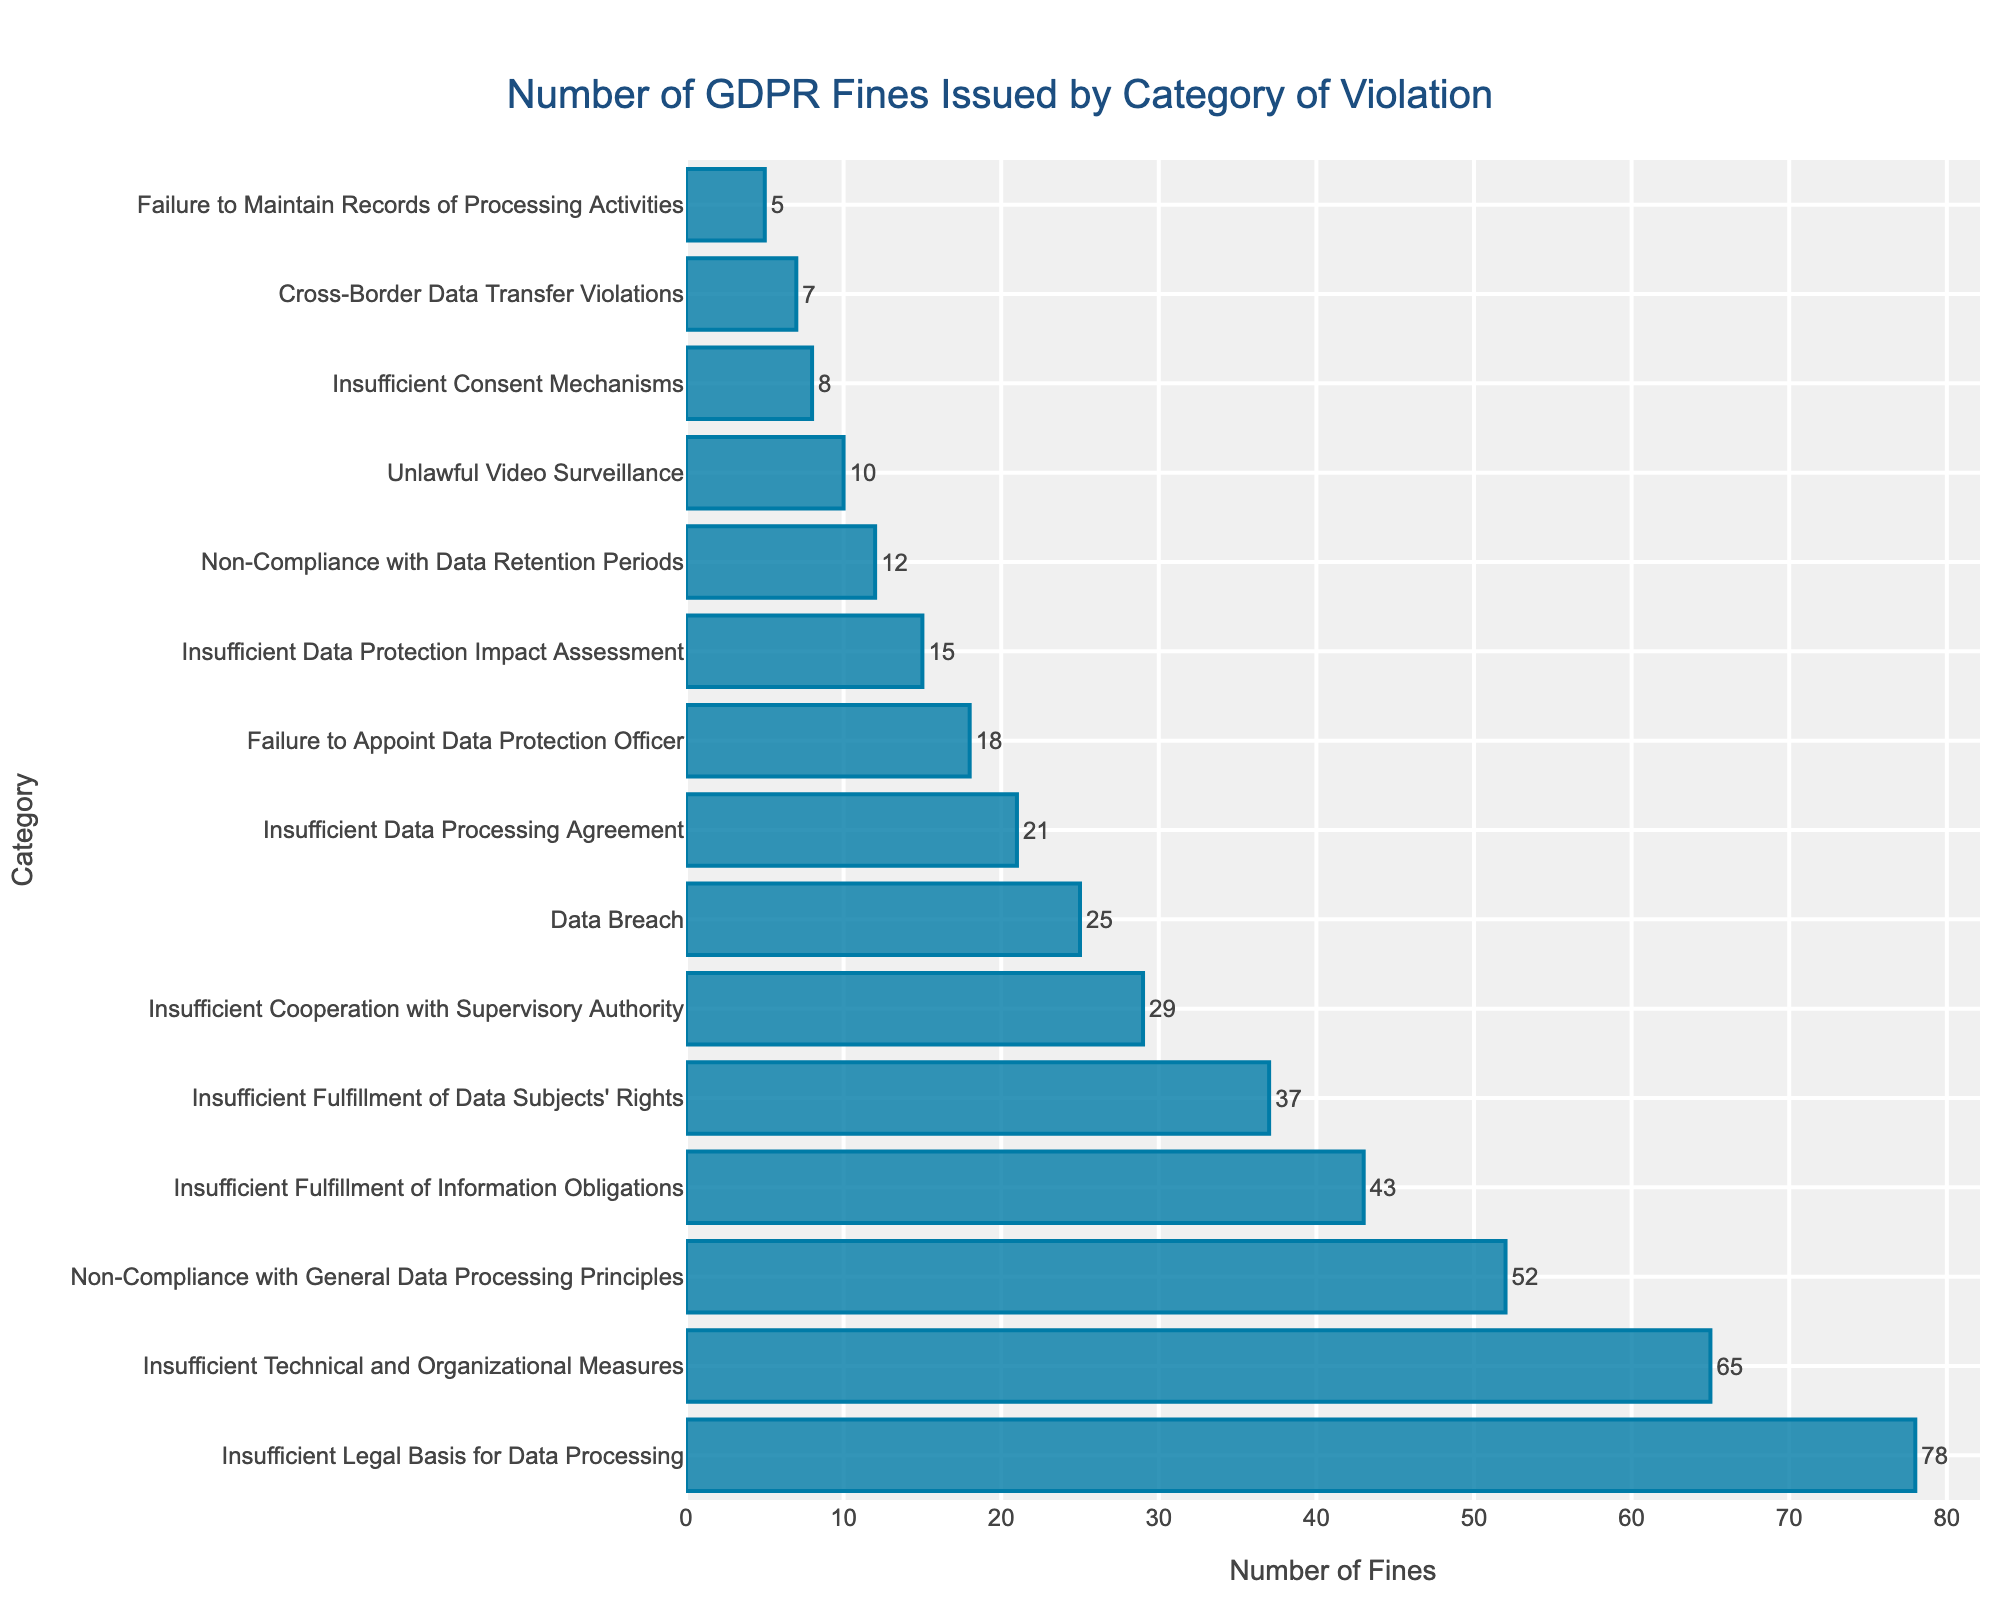Which category has the highest number of GDPR fines? By looking at the length of the bars, the longest bar represents the category with the highest number of fines. The category "Insufficient Legal Basis for Data Processing" has the longest bar.
Answer: Insufficient Legal Basis for Data Processing How many more fines are issued for "Insufficient Legal Basis for Data Processing" compared to "Data Breach"? The number of fines for "Insufficient Legal Basis for Data Processing" is 78 and for "Data Breach" is 25. The difference is calculated by 78 - 25.
Answer: 53 Which category has fewer fines, "Non-Compliance with Data Retention Periods" or "Unlawful Video Surveillance"? "Non-Compliance with Data Retention Periods" has 12 fines and "Unlawful Video Surveillance" has 10 fines. Since 10 is less than 12, "Unlawful Video Surveillance" has fewer fines.
Answer: Unlawful Video Surveillance What is the total number of GDPR fines in the top 3 categories combined? The top 3 categories by number of fines are "Insufficient Legal Basis for Data Processing" (78), "Insufficient Technical and Organizational Measures" (65), and "Non-Compliance with General Data Processing Principles" (52). The total is calculated by adding 78 + 65 + 52.
Answer: 195 Rank the following categories by the number of fines from highest to lowest: "Failure to Appoint Data Protection Officer", "Insufficient Data Processing Agreement", "Insufficient Data Protection Impact Assessment". Look at the numbers for each category: "Failure to Appoint Data Protection Officer" (18), "Insufficient Data Processing Agreement" (21), and "Insufficient Data Protection Impact Assessment" (15). Ranking them from highest to lowest: "Insufficient Data Processing Agreement" (21), "Failure to Appoint Data Protection Officer" (18), "Insufficient Data Protection Impact Assessment" (15).
Answer: Insufficient Data Processing Agreement, Failure to Appoint Data Protection Officer, Insufficient Data Protection Impact Assessment How many categories have fewer than 20 fines? Count the number of categories from the data where the number of fines is less than 20. The applicable categories are "Insufficient Data Processing Agreement" (21), which is greater than 20, so start counting from "Failure to Appoint Data Protection Officer" (18) and below. In total, there are 8 categories with fewer than 20 fines.
Answer: 8 Which has more fines: "Insufficient Fulfillment of Information Obligations" or the combined fines for "Failure to Maintain Records of Processing Activities" and "Cross-Border Data Transfer Violations"? "Insufficient Fulfillment of Information Obligations" has 43 fines. "Failure to Maintain Records of Processing Activities" has 5 fines and "Cross-Border Data Transfer Violations" has 7 fines. Their combined fines are 5 + 7 = 12. Comparing 43 and 12, "Insufficient Fulfillment of Information Obligations" has more fines.
Answer: Insufficient Fulfillment of Information Obligations 